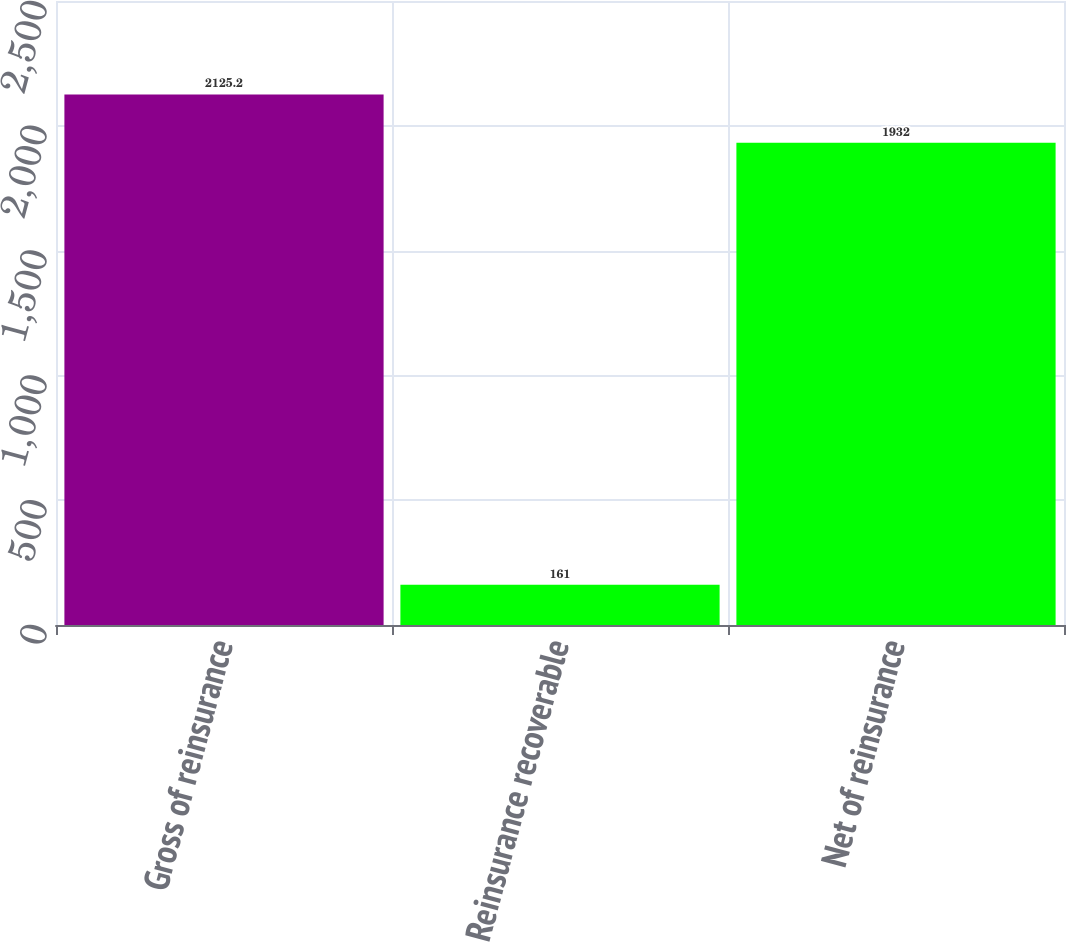Convert chart to OTSL. <chart><loc_0><loc_0><loc_500><loc_500><bar_chart><fcel>Gross of reinsurance<fcel>Reinsurance recoverable<fcel>Net of reinsurance<nl><fcel>2125.2<fcel>161<fcel>1932<nl></chart> 